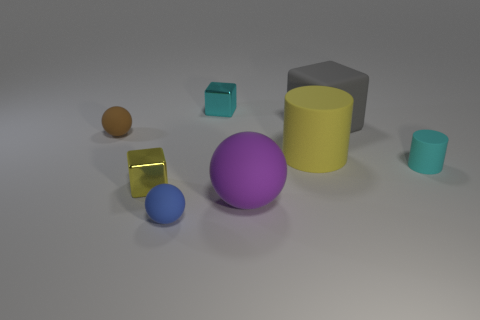Add 1 large gray shiny spheres. How many objects exist? 9 Subtract all spheres. How many objects are left? 5 Add 3 cyan matte blocks. How many cyan matte blocks exist? 3 Subtract 0 blue cylinders. How many objects are left? 8 Subtract all tiny metallic blocks. Subtract all purple balls. How many objects are left? 5 Add 1 large purple objects. How many large purple objects are left? 2 